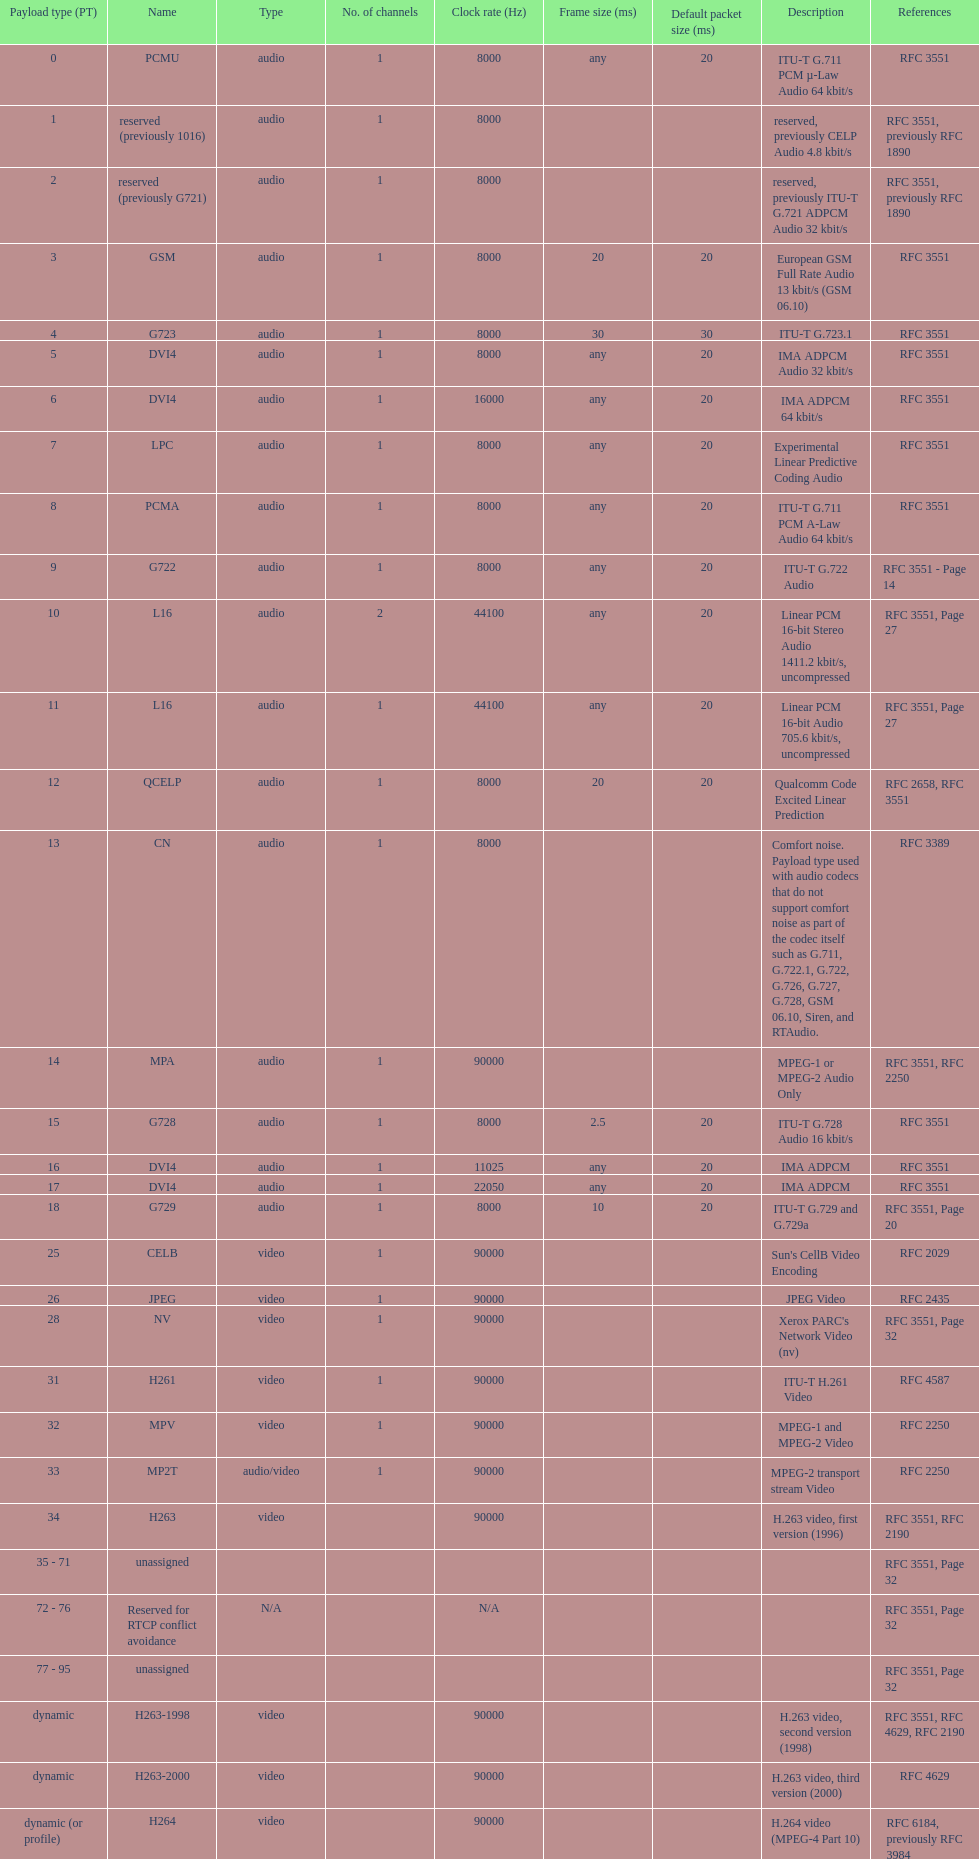Apart from audio, what are the other payload varieties? Video. 